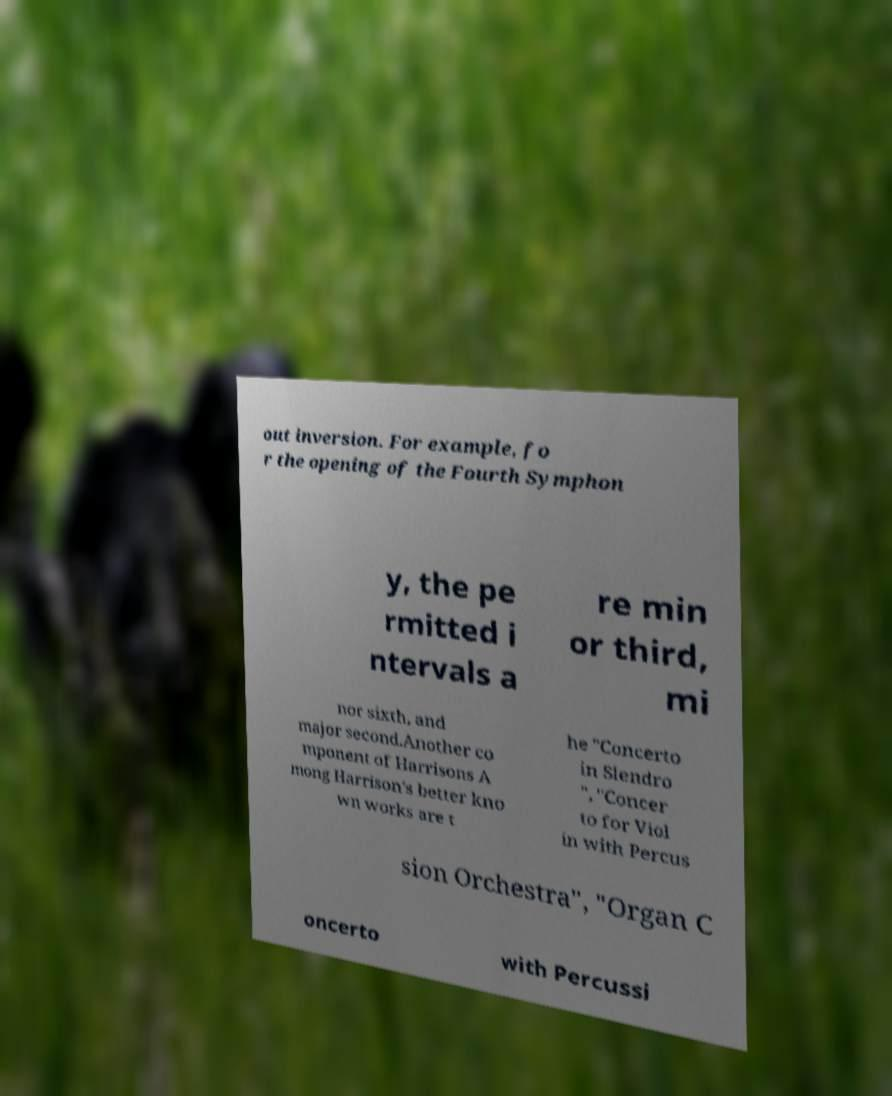For documentation purposes, I need the text within this image transcribed. Could you provide that? out inversion. For example, fo r the opening of the Fourth Symphon y, the pe rmitted i ntervals a re min or third, mi nor sixth, and major second.Another co mponent of Harrisons A mong Harrison's better kno wn works are t he "Concerto in Slendro ", "Concer to for Viol in with Percus sion Orchestra", "Organ C oncerto with Percussi 